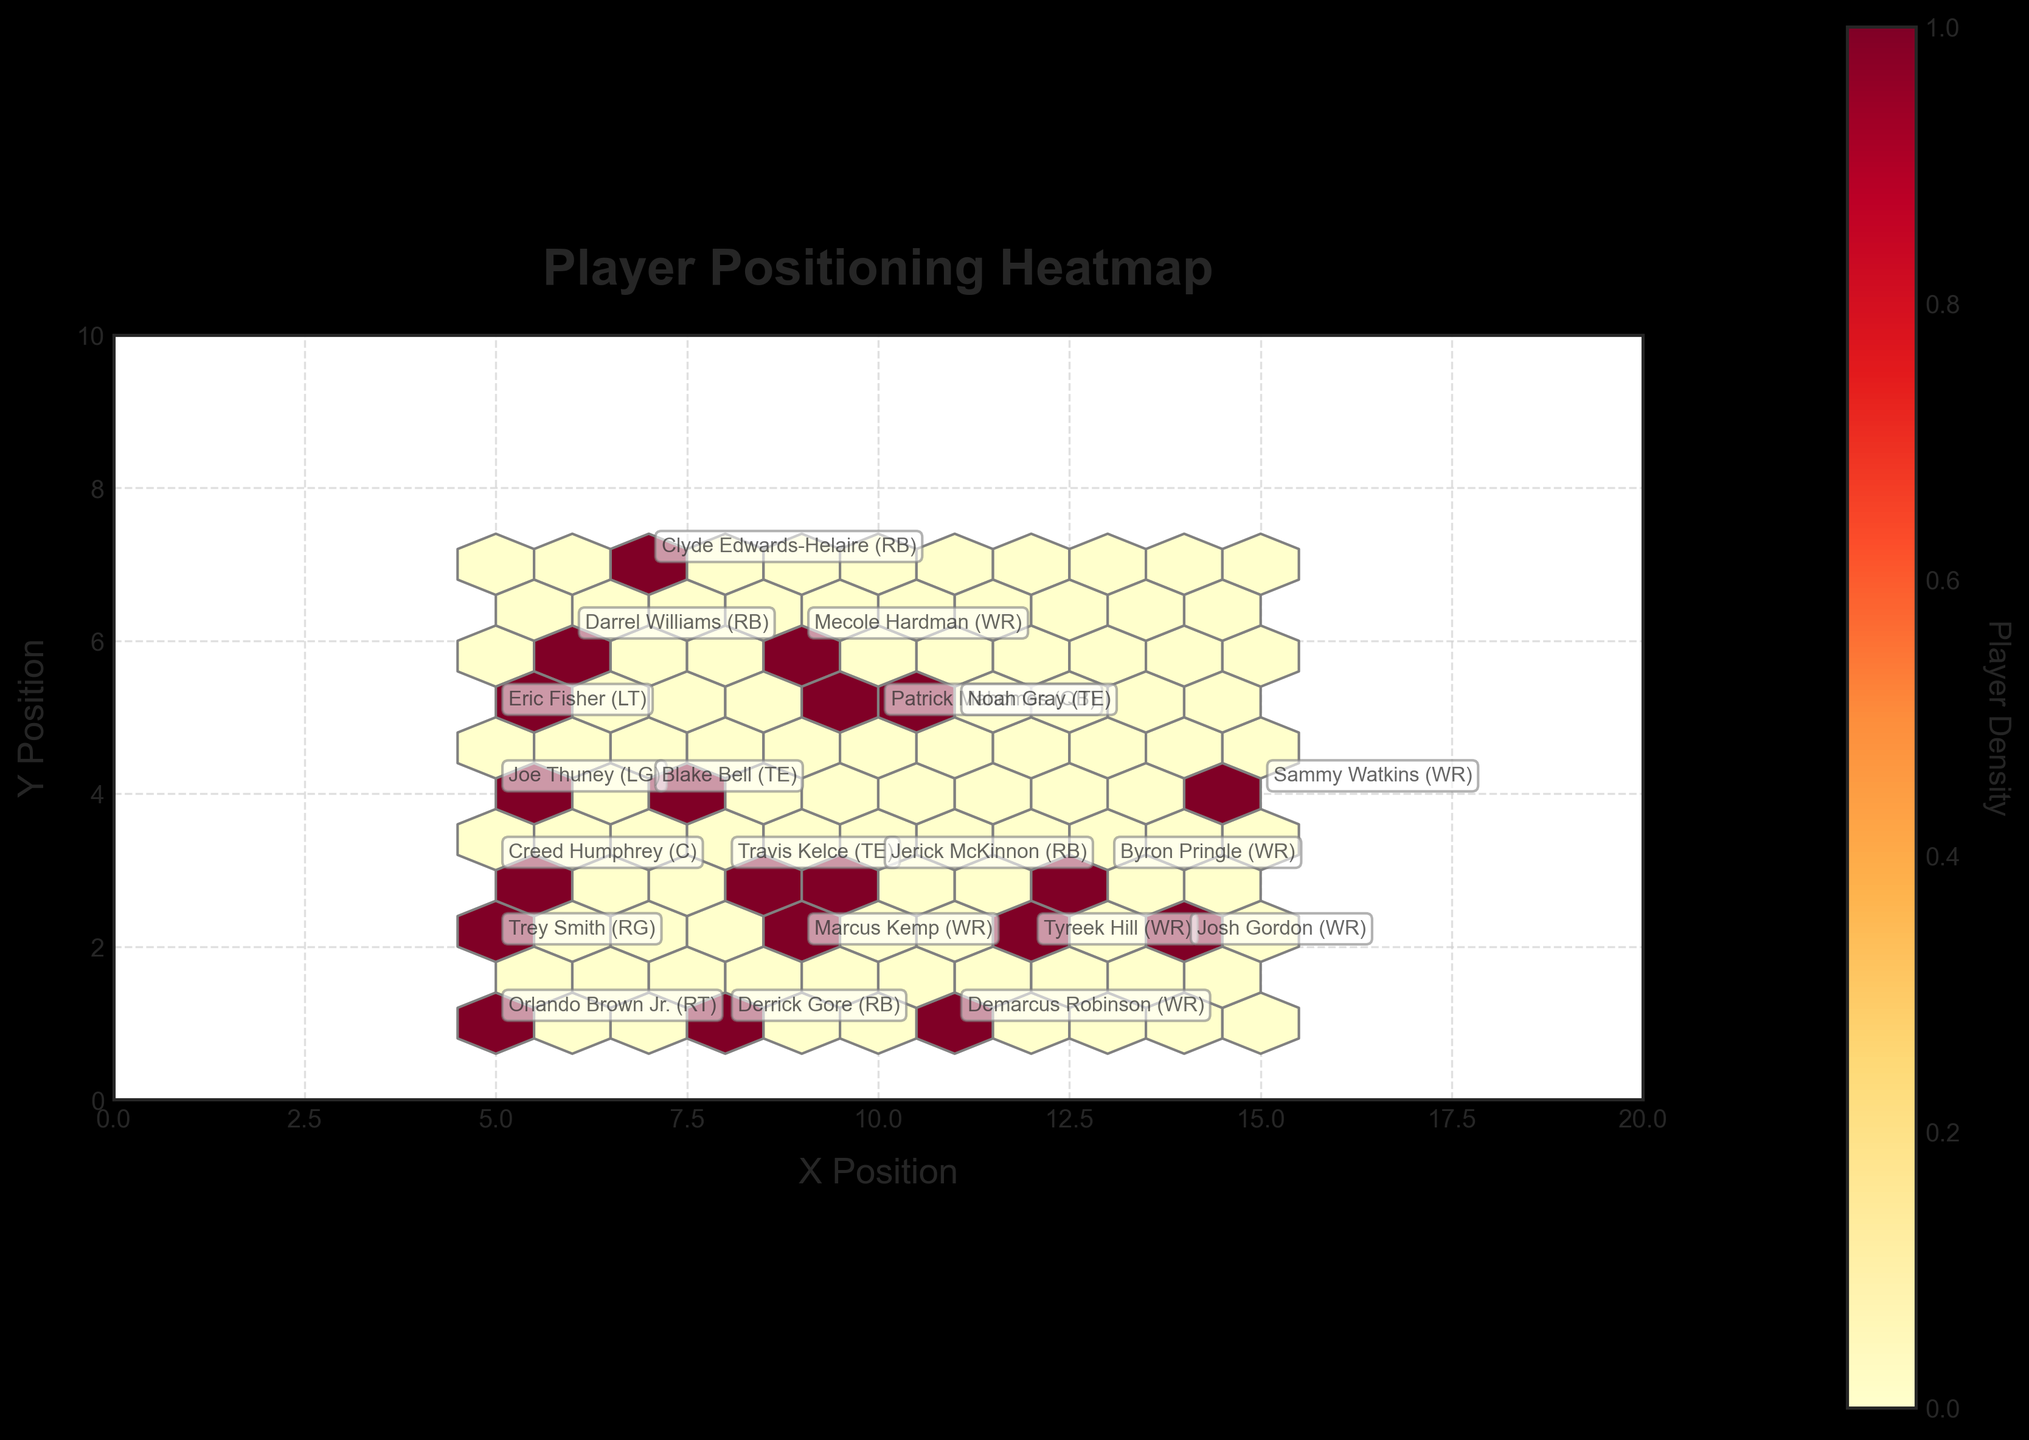What's the title of the plot? The title is displayed at the top of the figure in bold and larger font size. It directly states the overall theme of the plot.
Answer: Player Positioning Heatmap What is the axis label for the X Position? The label for the axis describing the horizontal position is found below the axis, providing context for the values along the X-axis.
Answer: X Position What color indicates the highest player density on the hexbin plot? In a hexbin plot with a YlOrRd color scheme, 'YlOrRd' stands for yellow to red, where darker colors typically represent higher densities.
Answer: Dark red Where is Patrick Mahomes positioned on the field in this plot? Look for the annotation with Patrick Mahomes' name next to a specific point on the plot.
Answer: (10, 5) Which position groups the most in a single area based on the density visualization? By observing the areas with the highest density in the hexbin plot, identify which position appears most frequently.
Answer: Offensive Linemen (centered around (5, 3)) Which player is positioned closest to the center of the plot? The center of the plot corresponds to a point (10, 5). Check for the nearest player annotations around this point.
Answer: Patrick Mahomes (QB) Which wide receiver (WR) is positioned the furthest from (7,7) on the plot? Calculate the Euclidean distance from (7,7) to each WR's position and identify the maximum distance.
Answer: Tyreek Hill (WR) Compare the positions of Travis Kelce and Blake Bell. Who is positioned closer to the right sideline? Travis Kelce is at (8, 3) and Blake Bell is at (7, 4). The right sideline is towards the higher X values. Compare their X coordinates.
Answer: Travis Kelce What is the average X position for all players classified as running backs (RB)? Running backs are positioned at (7, 7), (6, 6), (8, 1), (10, 3). Calculate the mean of their X-coordinates: (7+6+8+10)/4 = 31/4 = 7.75.
Answer: 7.75 